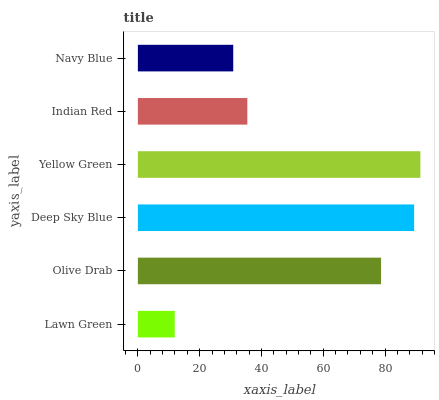Is Lawn Green the minimum?
Answer yes or no. Yes. Is Yellow Green the maximum?
Answer yes or no. Yes. Is Olive Drab the minimum?
Answer yes or no. No. Is Olive Drab the maximum?
Answer yes or no. No. Is Olive Drab greater than Lawn Green?
Answer yes or no. Yes. Is Lawn Green less than Olive Drab?
Answer yes or no. Yes. Is Lawn Green greater than Olive Drab?
Answer yes or no. No. Is Olive Drab less than Lawn Green?
Answer yes or no. No. Is Olive Drab the high median?
Answer yes or no. Yes. Is Indian Red the low median?
Answer yes or no. Yes. Is Deep Sky Blue the high median?
Answer yes or no. No. Is Yellow Green the low median?
Answer yes or no. No. 